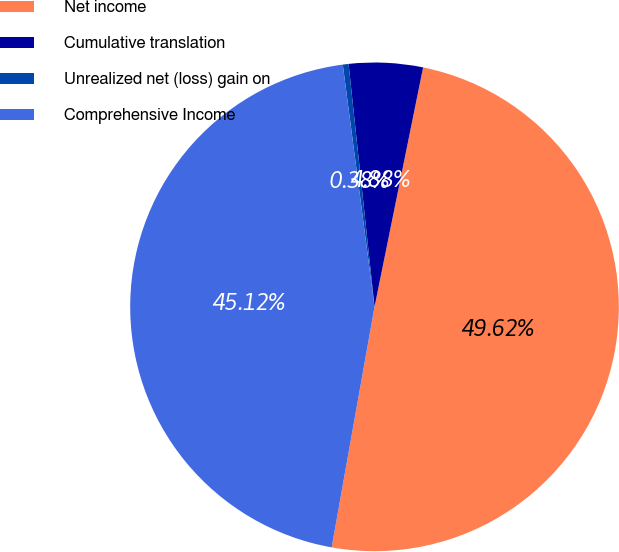Convert chart to OTSL. <chart><loc_0><loc_0><loc_500><loc_500><pie_chart><fcel>Net income<fcel>Cumulative translation<fcel>Unrealized net (loss) gain on<fcel>Comprehensive Income<nl><fcel>49.62%<fcel>4.88%<fcel>0.38%<fcel>45.12%<nl></chart> 